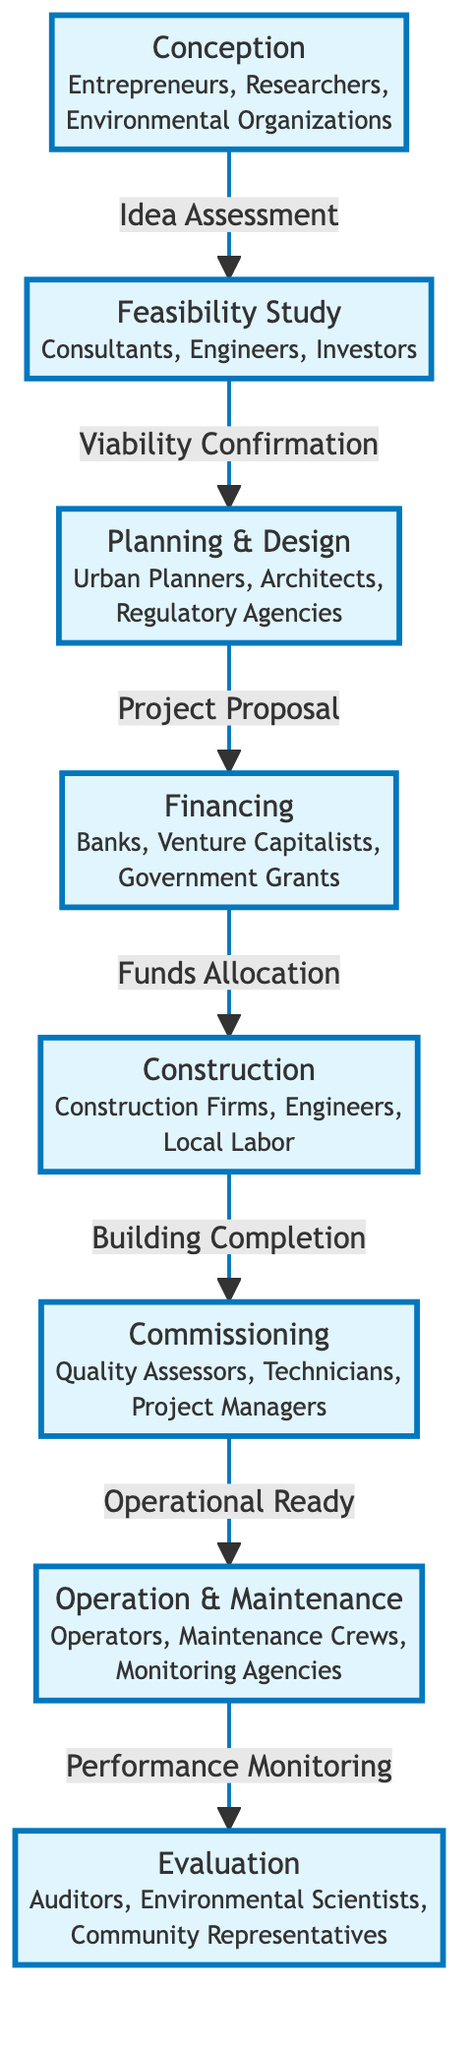What is the first stage in the Life Cycle of a Renewable Energy Project? The diagram begins with the "Conception" stage, which is the starting point for the life cycle of the project.
Answer: Conception How many stakeholders are involved in the "Planning & Design" stage? The "Planning & Design" stage involves three stakeholders listed: Urban Planners, Architects, and Regulatory Agencies.
Answer: Three What is the last stage before "Operation & Maintenance"? According to the flow of the diagram, the last stage before "Operation & Maintenance" is "Commissioning".
Answer: Commissioning Which stage follows "Financing"? The diagram indicates that "Construction" is the stage that directly follows "Financing" in the project life cycle.
Answer: Construction Who are the stakeholders in the "Feasibility Study" stage? The stakeholders identified for the "Feasibility Study" stage are Consultants, Engineers, and Investors, as listed in the diagram.
Answer: Consultants, Engineers, Investors What is the connection between "Construction" and "Commissioning"? The connection between "Construction" and "Commissioning" is denoted as "Building Completion", indicating that once construction is completed, commissioning follows.
Answer: Building Completion Which two stages are directly connected with a milestone label? The stages "Planning & Design" and "Financing" are connected by the milestone label "Project Proposal".
Answer: Project Proposal How does "Operation & Maintenance" relate to "Evaluation"? The relationship is defined by "Performance Monitoring", signifying that after operation and maintenance, an evaluation phase occurs based on performance metrics.
Answer: Performance Monitoring What is the total number of nodes in the diagram? The diagram consists of eight distinct nodes, each representing a key stage in the life cycle of a renewable energy project.
Answer: Eight 